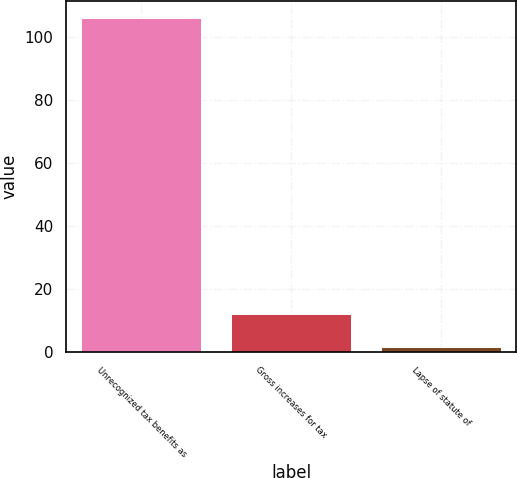<chart> <loc_0><loc_0><loc_500><loc_500><bar_chart><fcel>Unrecognized tax benefits as<fcel>Gross increases for tax<fcel>Lapse of statute of<nl><fcel>106.2<fcel>12.15<fcel>1.7<nl></chart> 